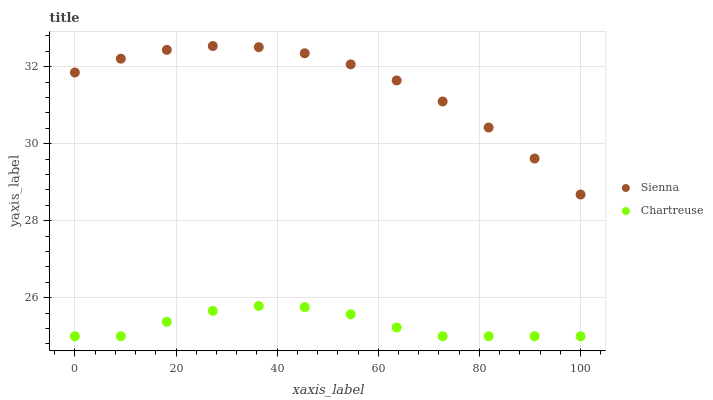Does Chartreuse have the minimum area under the curve?
Answer yes or no. Yes. Does Sienna have the maximum area under the curve?
Answer yes or no. Yes. Does Chartreuse have the maximum area under the curve?
Answer yes or no. No. Is Sienna the smoothest?
Answer yes or no. Yes. Is Chartreuse the roughest?
Answer yes or no. Yes. Is Chartreuse the smoothest?
Answer yes or no. No. Does Chartreuse have the lowest value?
Answer yes or no. Yes. Does Sienna have the highest value?
Answer yes or no. Yes. Does Chartreuse have the highest value?
Answer yes or no. No. Is Chartreuse less than Sienna?
Answer yes or no. Yes. Is Sienna greater than Chartreuse?
Answer yes or no. Yes. Does Chartreuse intersect Sienna?
Answer yes or no. No. 